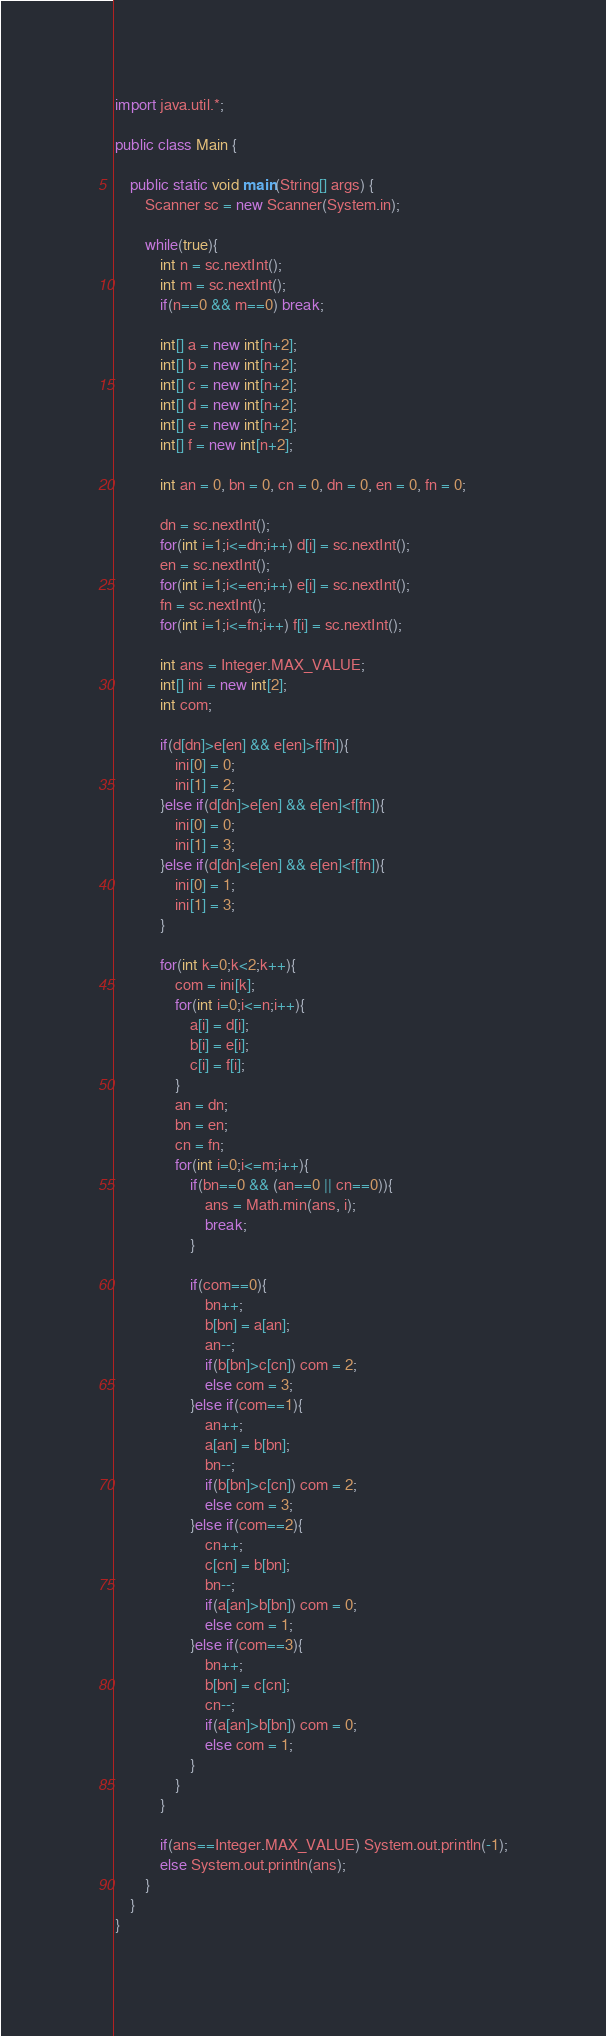<code> <loc_0><loc_0><loc_500><loc_500><_Java_>import java.util.*;

public class Main {
	
	public static void main(String[] args) {
		Scanner sc = new Scanner(System.in);
		
		while(true){
			int n = sc.nextInt();
			int m = sc.nextInt();
			if(n==0 && m==0) break;
			
			int[] a = new int[n+2];
			int[] b = new int[n+2];
			int[] c = new int[n+2];
			int[] d = new int[n+2];
			int[] e = new int[n+2];
			int[] f = new int[n+2];
			
			int an = 0, bn = 0, cn = 0, dn = 0, en = 0, fn = 0;
			
			dn = sc.nextInt();
			for(int i=1;i<=dn;i++) d[i] = sc.nextInt();
			en = sc.nextInt();
			for(int i=1;i<=en;i++) e[i] = sc.nextInt();
			fn = sc.nextInt();
			for(int i=1;i<=fn;i++) f[i] = sc.nextInt();
			
			int ans = Integer.MAX_VALUE;
			int[] ini = new int[2];
			int com;
			
			if(d[dn]>e[en] && e[en]>f[fn]){
				ini[0] = 0;
				ini[1] = 2;
			}else if(d[dn]>e[en] && e[en]<f[fn]){
				ini[0] = 0;
				ini[1] = 3;
			}else if(d[dn]<e[en] && e[en]<f[fn]){
				ini[0] = 1;
				ini[1] = 3;
			}
			
			for(int k=0;k<2;k++){
				com = ini[k];
				for(int i=0;i<=n;i++){
					a[i] = d[i];
					b[i] = e[i];
					c[i] = f[i];
				}
				an = dn;
				bn = en;
				cn = fn;
				for(int i=0;i<=m;i++){
					if(bn==0 && (an==0 || cn==0)){
						ans = Math.min(ans, i);
						break;
					}
					
					if(com==0){
						bn++;
						b[bn] = a[an];
						an--;
						if(b[bn]>c[cn]) com = 2;
						else com = 3;
					}else if(com==1){
						an++;
						a[an] = b[bn];
						bn--;
						if(b[bn]>c[cn]) com = 2;
						else com = 3;
					}else if(com==2){
						cn++;
						c[cn] = b[bn];
						bn--;
						if(a[an]>b[bn]) com = 0;
						else com = 1;
					}else if(com==3){
						bn++;
						b[bn] = c[cn];
						cn--;
						if(a[an]>b[bn]) com = 0;
						else com = 1;
					}
				}
			}
			
			if(ans==Integer.MAX_VALUE) System.out.println(-1);
			else System.out.println(ans);
		}	
	}	
}</code> 